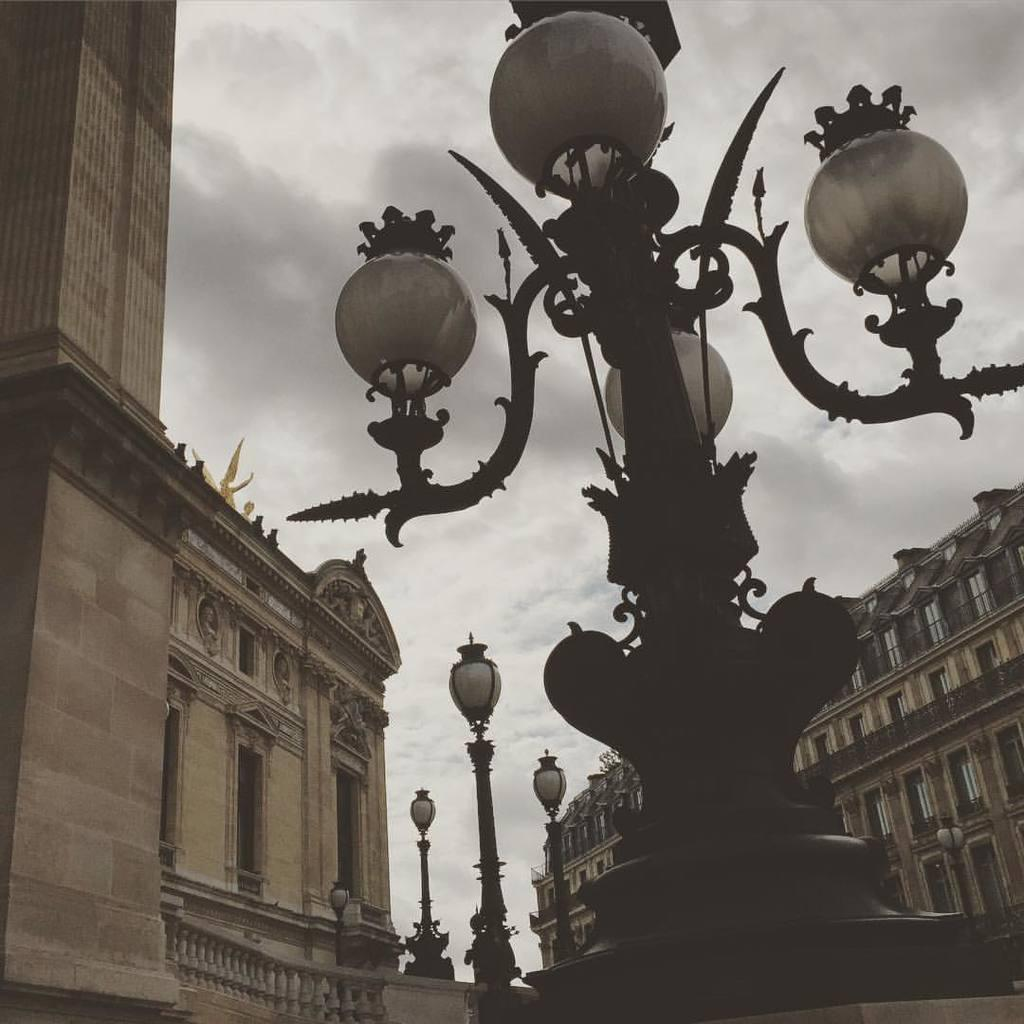What type of structures can be seen in the image? There are street lights, poles, walls, buildings, and railings visible in the image. What architectural features are present in the image? The image includes walls, buildings, and railings. What can be seen on the buildings in the image? There are windows visible on the buildings in the image. What is the condition of the sky in the background of the image? The background of the image includes a cloudy sky. What type of pencil can be seen in the image? There is no pencil present in the image. How many attempts were made to trick the street lights in the image? There is no indication of any attempts to trick the street lights in the image. 